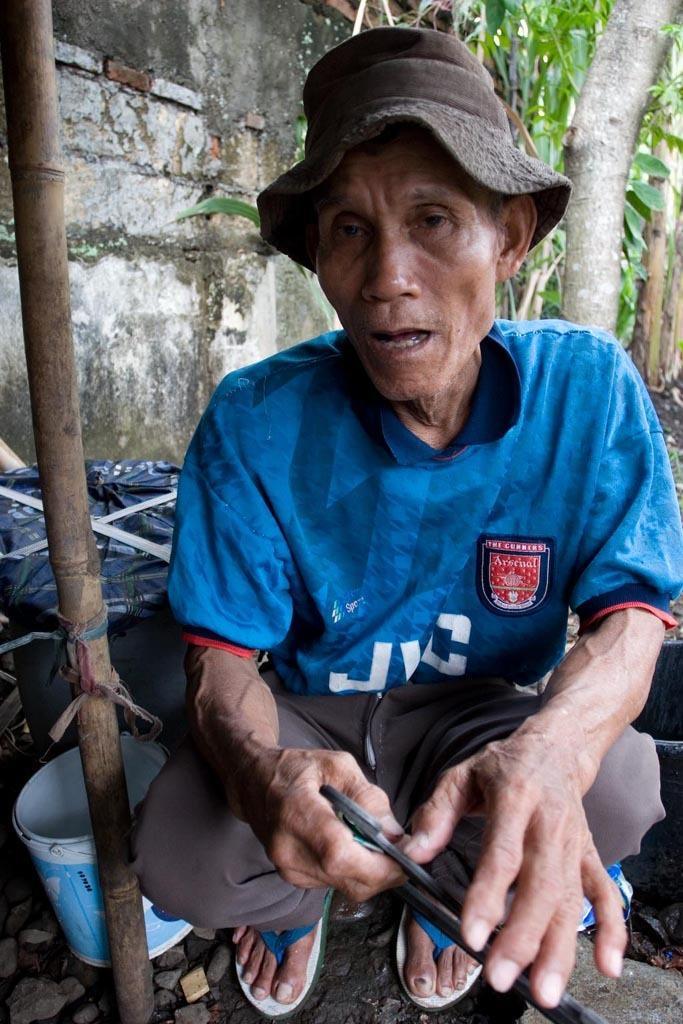Could you give a brief overview of what you see in this image? In the image a person is sitting and holding something in his hand. Behind him there is a tub and there are some trees and wall. Bottom left side of the image there is a stick. 